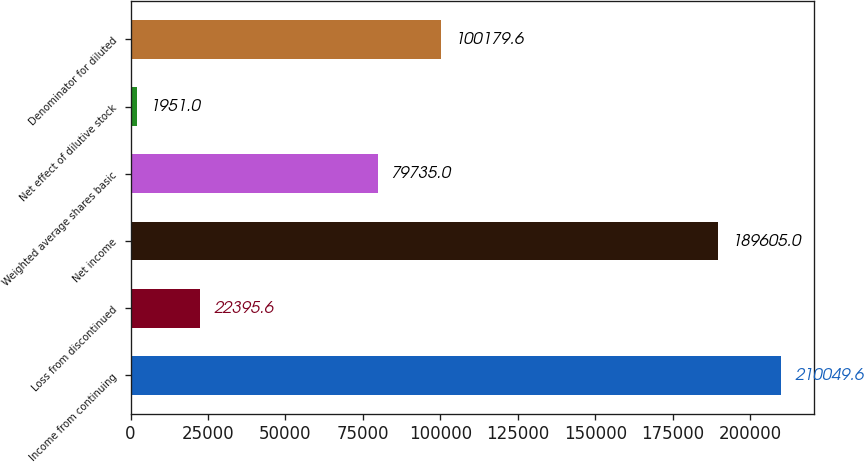Convert chart. <chart><loc_0><loc_0><loc_500><loc_500><bar_chart><fcel>Income from continuing<fcel>Loss from discontinued<fcel>Net income<fcel>Weighted average shares basic<fcel>Net effect of dilutive stock<fcel>Denominator for diluted<nl><fcel>210050<fcel>22395.6<fcel>189605<fcel>79735<fcel>1951<fcel>100180<nl></chart> 